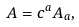Convert formula to latex. <formula><loc_0><loc_0><loc_500><loc_500>A = c ^ { a } A _ { a } ,</formula> 